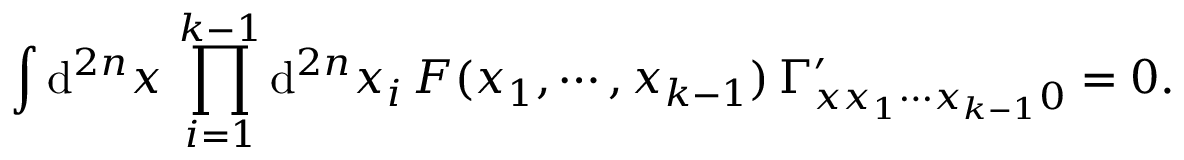<formula> <loc_0><loc_0><loc_500><loc_500>\int d ^ { 2 n } x \, \prod _ { i = 1 } ^ { k - 1 } d ^ { 2 n } x _ { i } \, F ( x _ { 1 } , \cdots , x _ { k - 1 } ) \, \Gamma _ { x x _ { 1 } \cdots x _ { k - 1 } 0 } ^ { \prime } = 0 .</formula> 